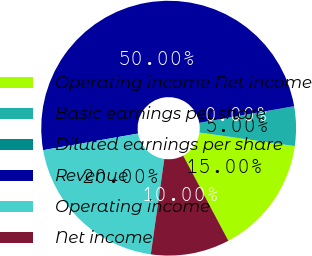Convert chart to OTSL. <chart><loc_0><loc_0><loc_500><loc_500><pie_chart><fcel>Operating income Net income<fcel>Basic earnings per share<fcel>Diluted earnings per share<fcel>Revenue<fcel>Operating income<fcel>Net income<nl><fcel>15.0%<fcel>5.0%<fcel>0.0%<fcel>50.0%<fcel>20.0%<fcel>10.0%<nl></chart> 